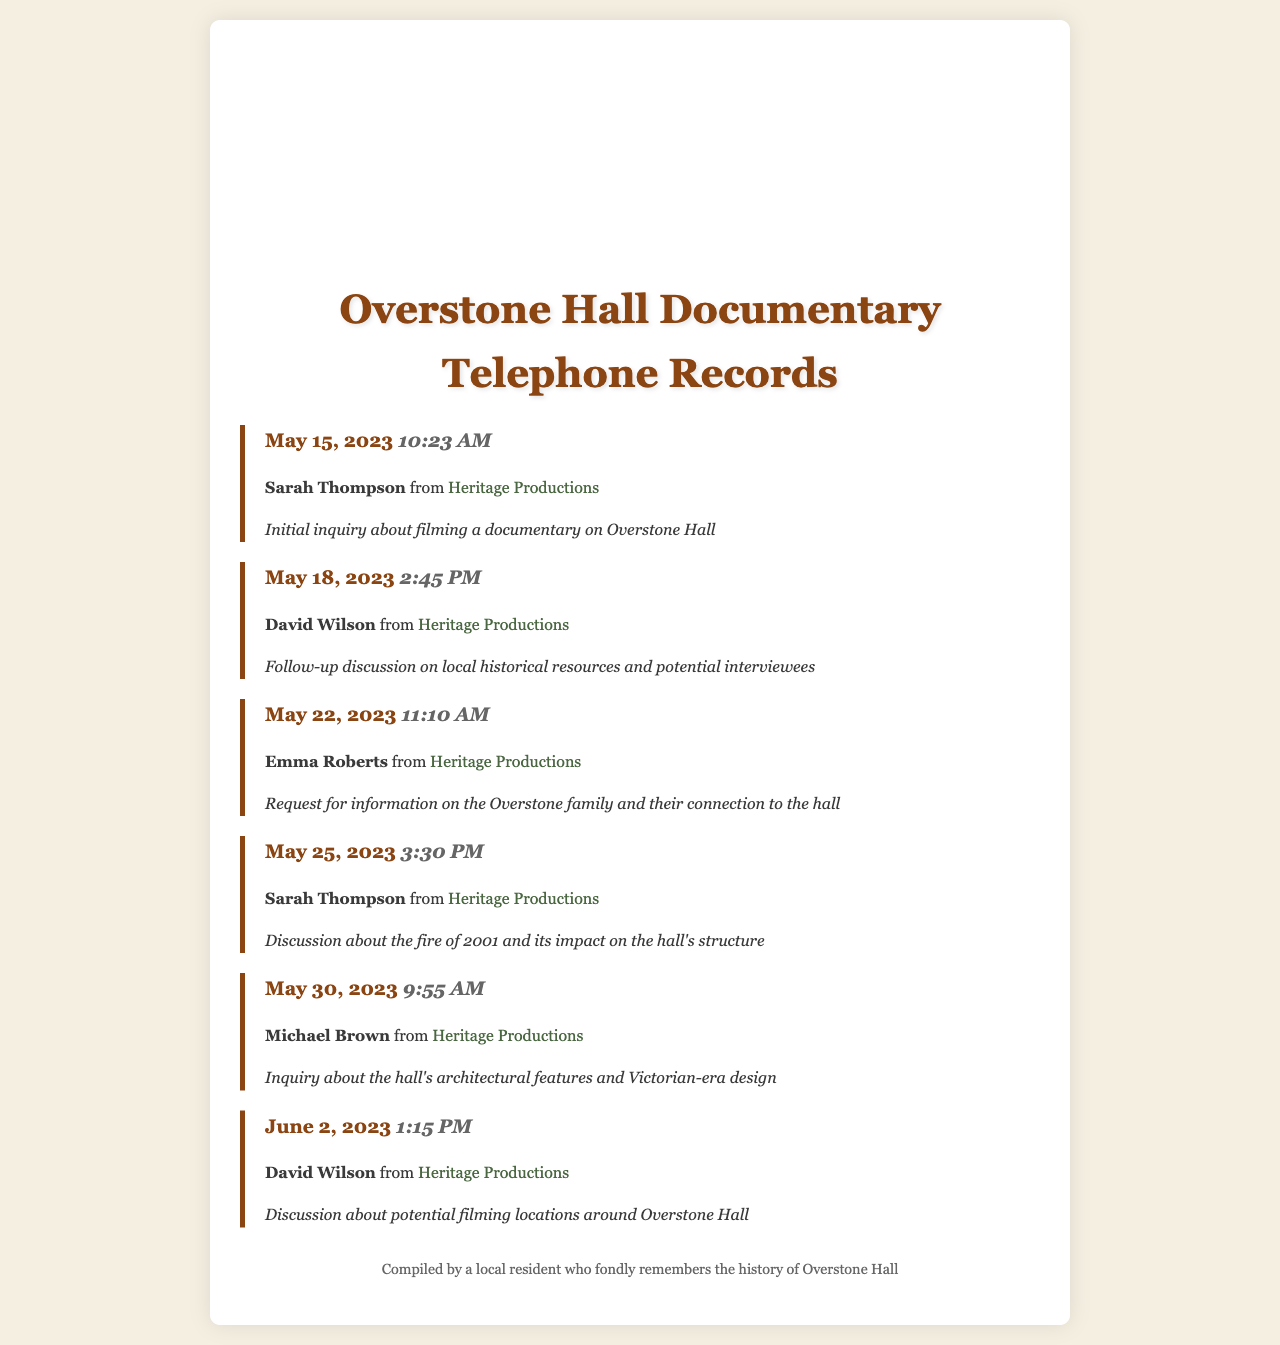What was the date of the first call? The first call took place on May 15, 2023, as indicated in the log.
Answer: May 15, 2023 Who was the caller during the third call? The third call was made by Emma Roberts according to the telephone records.
Answer: Emma Roberts How many calls were made by David Wilson? David Wilson is mentioned as the caller in two entries in the document.
Answer: Two What was the purpose of the last call made in the document? The last call's purpose was to discuss potential filming locations around Overstone Hall.
Answer: Discussion about potential filming locations Which company is interested in filming the documentary? All calls were made by individuals representing the same production company interested in the project.
Answer: Heritage Productions What was addressed in the call on May 25, 2023? The focus of the call on May 25, 2023, was the fire of 2001 and its impact on the hall's structure.
Answer: Fire of 2001 What type of document is this? This document contains a record of phone calls regarding a specific project, outlining the details of each conversation.
Answer: Telephone records What time was the last call made? The last recorded call took place at 1:15 PM, as noted in the call log.
Answer: 1:15 PM 